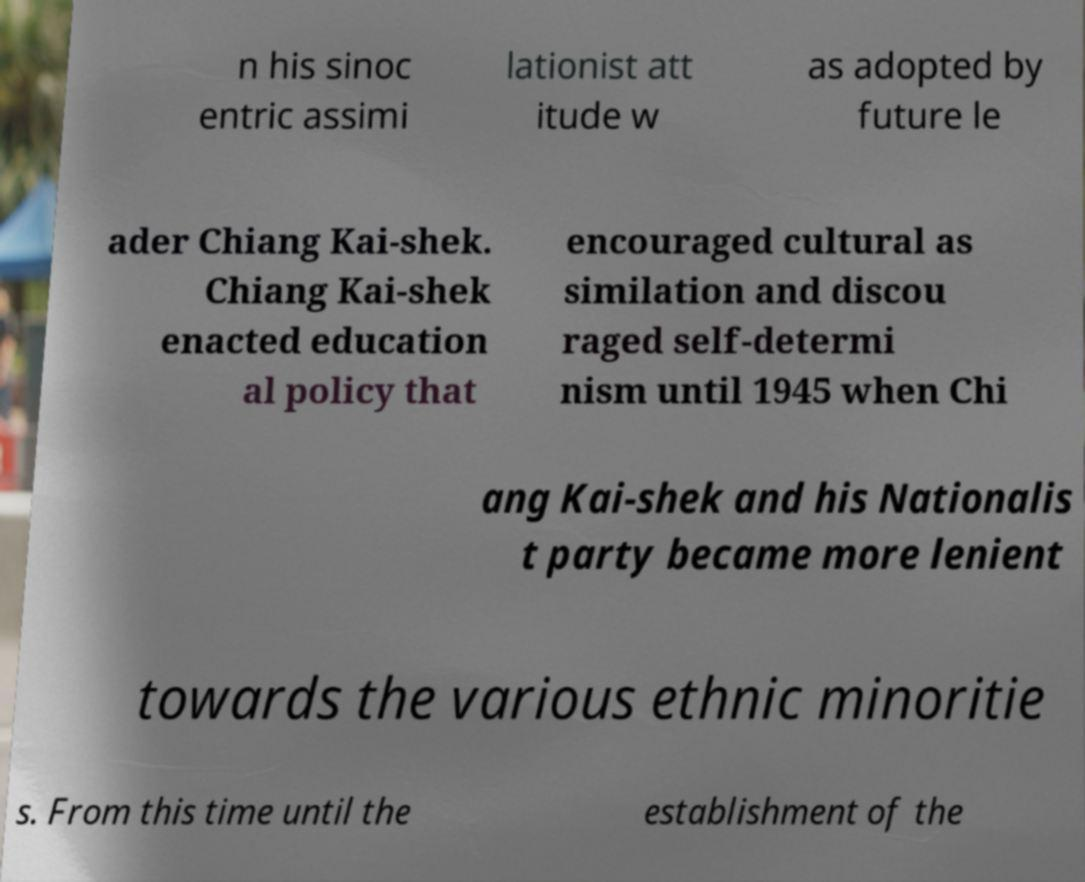Could you extract and type out the text from this image? n his sinoc entric assimi lationist att itude w as adopted by future le ader Chiang Kai-shek. Chiang Kai-shek enacted education al policy that encouraged cultural as similation and discou raged self-determi nism until 1945 when Chi ang Kai-shek and his Nationalis t party became more lenient towards the various ethnic minoritie s. From this time until the establishment of the 